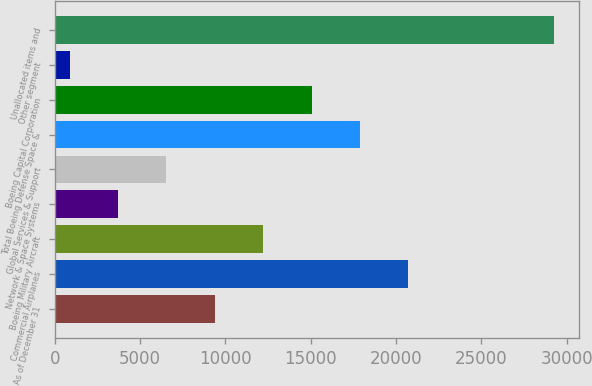<chart> <loc_0><loc_0><loc_500><loc_500><bar_chart><fcel>As of December 31<fcel>Commercial Airplanes<fcel>Boeing Military Aircraft<fcel>Network & Space Systems<fcel>Global Services & Support<fcel>Total Boeing Defense Space &<fcel>Boeing Capital Corporation<fcel>Other segment<fcel>Unallocated items and<nl><fcel>9378.8<fcel>20721.2<fcel>12214.4<fcel>3707.6<fcel>6543.2<fcel>17885.6<fcel>15050<fcel>872<fcel>29228<nl></chart> 